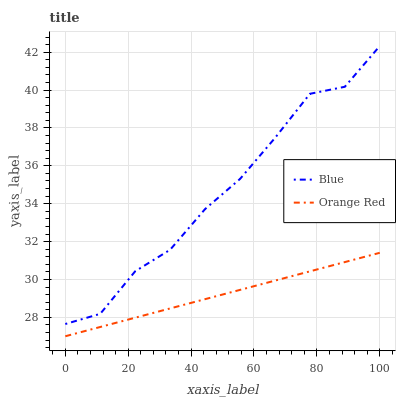Does Orange Red have the minimum area under the curve?
Answer yes or no. Yes. Does Blue have the maximum area under the curve?
Answer yes or no. Yes. Does Orange Red have the maximum area under the curve?
Answer yes or no. No. Is Orange Red the smoothest?
Answer yes or no. Yes. Is Blue the roughest?
Answer yes or no. Yes. Is Orange Red the roughest?
Answer yes or no. No. Does Orange Red have the lowest value?
Answer yes or no. Yes. Does Blue have the highest value?
Answer yes or no. Yes. Does Orange Red have the highest value?
Answer yes or no. No. Is Orange Red less than Blue?
Answer yes or no. Yes. Is Blue greater than Orange Red?
Answer yes or no. Yes. Does Orange Red intersect Blue?
Answer yes or no. No. 